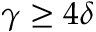<formula> <loc_0><loc_0><loc_500><loc_500>\gamma \geq 4 \delta</formula> 